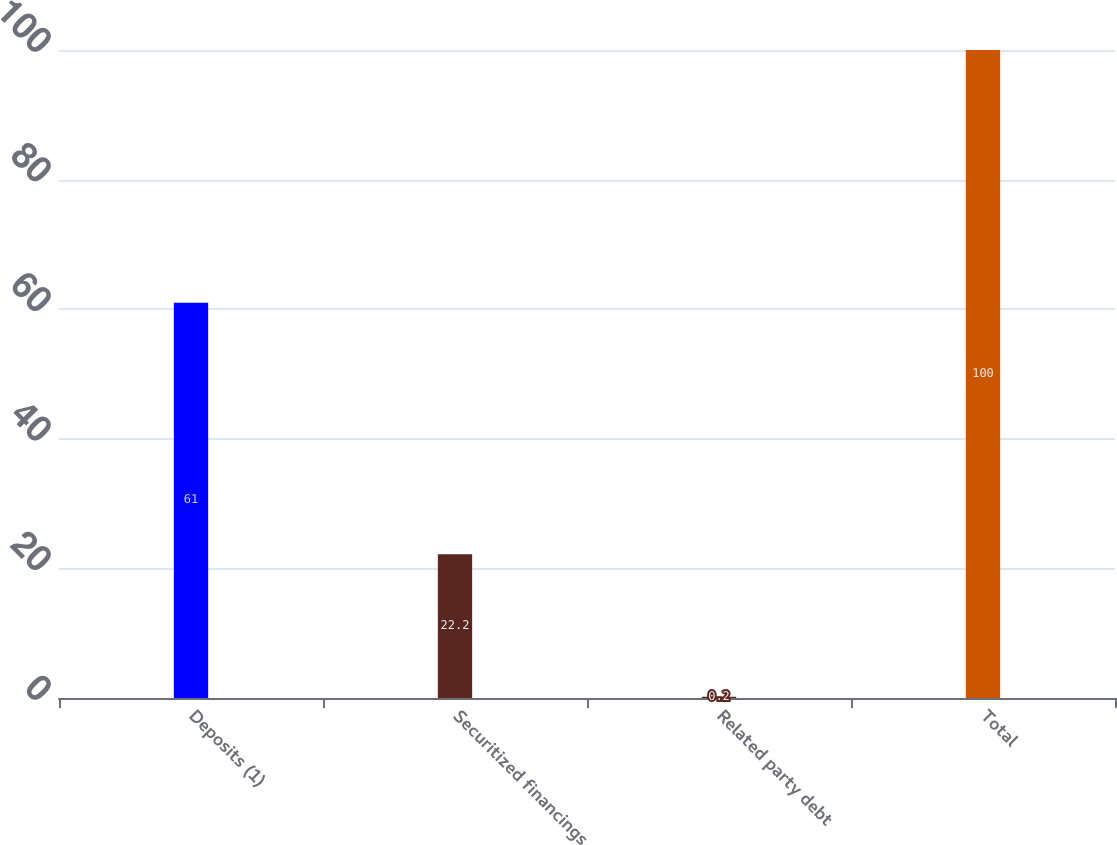Convert chart. <chart><loc_0><loc_0><loc_500><loc_500><bar_chart><fcel>Deposits (1)<fcel>Securitized financings<fcel>Related party debt<fcel>Total<nl><fcel>61<fcel>22.2<fcel>0.2<fcel>100<nl></chart> 